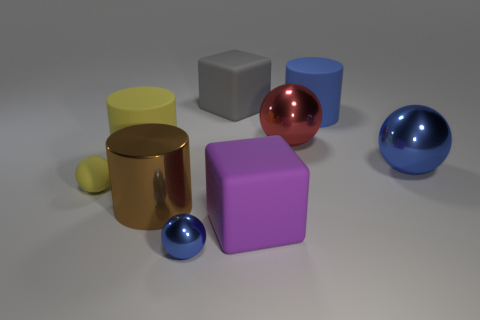Aside from shape, what other properties vary among these objects? The objects exhibit a variety of colors, including purple, red, blue, yellow, and gray. They also differ in size and material finish, with some having matte surfaces and others appearing more glossy. 